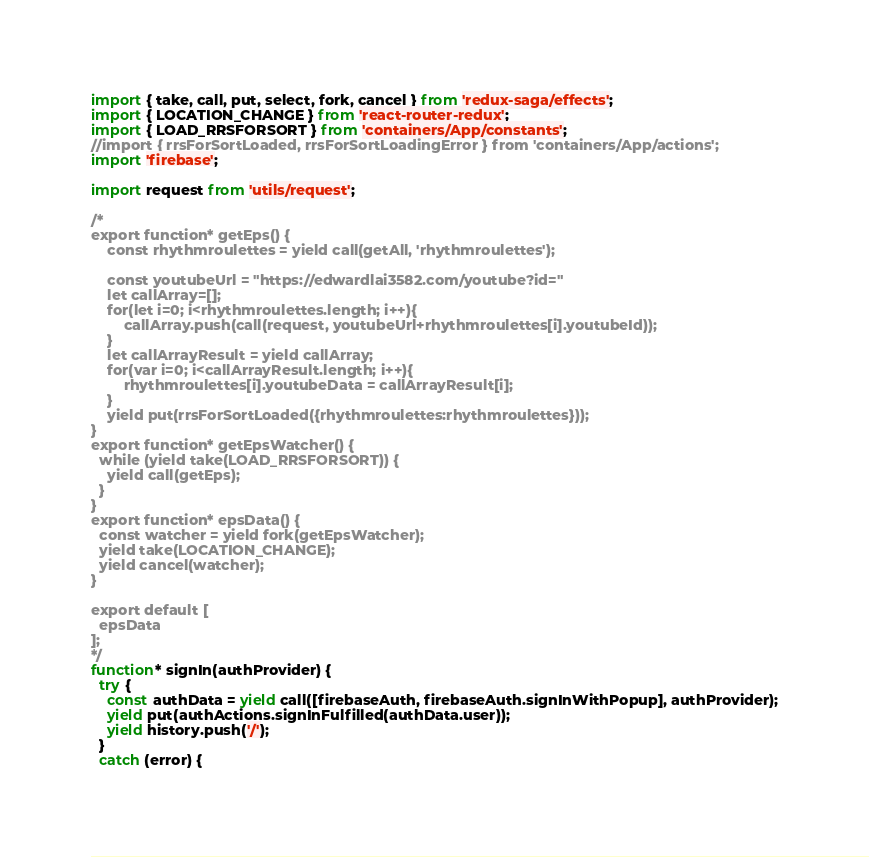Convert code to text. <code><loc_0><loc_0><loc_500><loc_500><_JavaScript_>import { take, call, put, select, fork, cancel } from 'redux-saga/effects';
import { LOCATION_CHANGE } from 'react-router-redux';
import { LOAD_RRSFORSORT } from 'containers/App/constants';
//import { rrsForSortLoaded, rrsForSortLoadingError } from 'containers/App/actions';
import 'firebase';

import request from 'utils/request';

/*
export function* getEps() {
    const rhythmroulettes = yield call(getAll, 'rhythmroulettes');

    const youtubeUrl = "https://edwardlai3582.com/youtube?id="
    let callArray=[];
    for(let i=0; i<rhythmroulettes.length; i++){
        callArray.push(call(request, youtubeUrl+rhythmroulettes[i].youtubeId));
    }      
    let callArrayResult = yield callArray;
    for(var i=0; i<callArrayResult.length; i++){
        rhythmroulettes[i].youtubeData = callArrayResult[i];    
    }
    yield put(rrsForSortLoaded({rhythmroulettes:rhythmroulettes}));
}
export function* getEpsWatcher() {
  while (yield take(LOAD_RRSFORSORT)) {
    yield call(getEps);
  }
}
export function* epsData() {
  const watcher = yield fork(getEpsWatcher);
  yield take(LOCATION_CHANGE);
  yield cancel(watcher);
}

export default [
  epsData    
];
*/
function* signIn(authProvider) {
  try {
    const authData = yield call([firebaseAuth, firebaseAuth.signInWithPopup], authProvider);
    yield put(authActions.signInFulfilled(authData.user));
    yield history.push('/');
  }
  catch (error) {</code> 